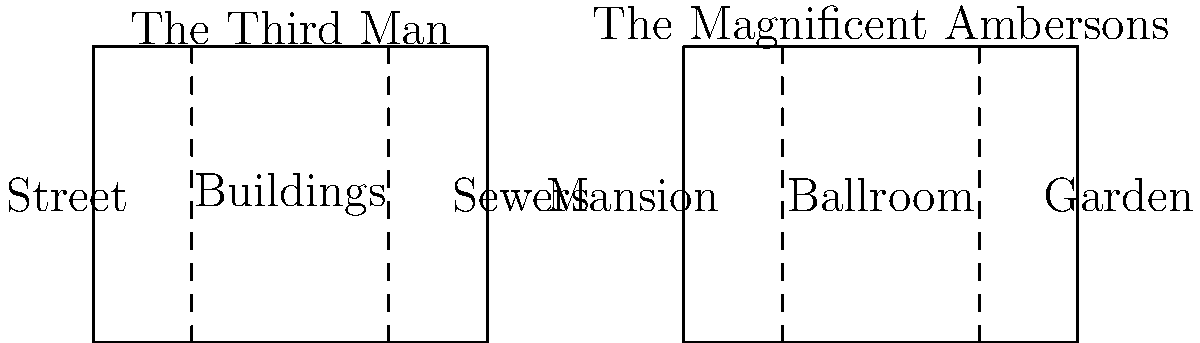Based on the set layout drawings provided, which film's mise-en-scène emphasizes a greater contrast between interior and exterior spaces, and how does this relate to the themes explored in each movie? To answer this question, let's analyze the set layouts for both films:

1. "The Third Man" layout:
   a. Divided into three sections: Street, Buildings, and Sewers
   b. Shows a progression from open exterior (Street) to enclosed interior (Buildings) to underground (Sewers)
   c. This layout emphasizes the film's themes of post-war Vienna, moral ambiguity, and the underground black market

2. "The Magnificent Ambersons" layout:
   a. Divided into three sections: Mansion, Ballroom, and Garden
   b. Focuses primarily on the Amberson mansion, with both interior (Mansion, Ballroom) and exterior (Garden) spaces
   c. This layout highlights the film's themes of family, social change, and the decline of aristocracy

3. Comparing the two layouts:
   a. "The Third Man" shows a more dramatic contrast between interior and exterior spaces
   b. It progresses from open streets to enclosed buildings to underground sewers
   c. This contrast reinforces the film's themes of moral ambiguity and hidden truths

4. "The Magnificent Ambersons" layout:
   a. Focuses more on the interplay between different spaces within a single property
   b. The contrast between interior and exterior is less pronounced
   c. This layout emphasizes the insular world of the Amberson family and their struggle with changing times

5. Conclusion:
   "The Third Man" emphasizes a greater contrast between interior and exterior spaces, which aligns with its themes of moral ambiguity, hidden truths, and the complex nature of post-war Vienna.
Answer: "The Third Man" emphasizes greater interior-exterior contrast, reflecting themes of moral ambiguity and hidden truths. 